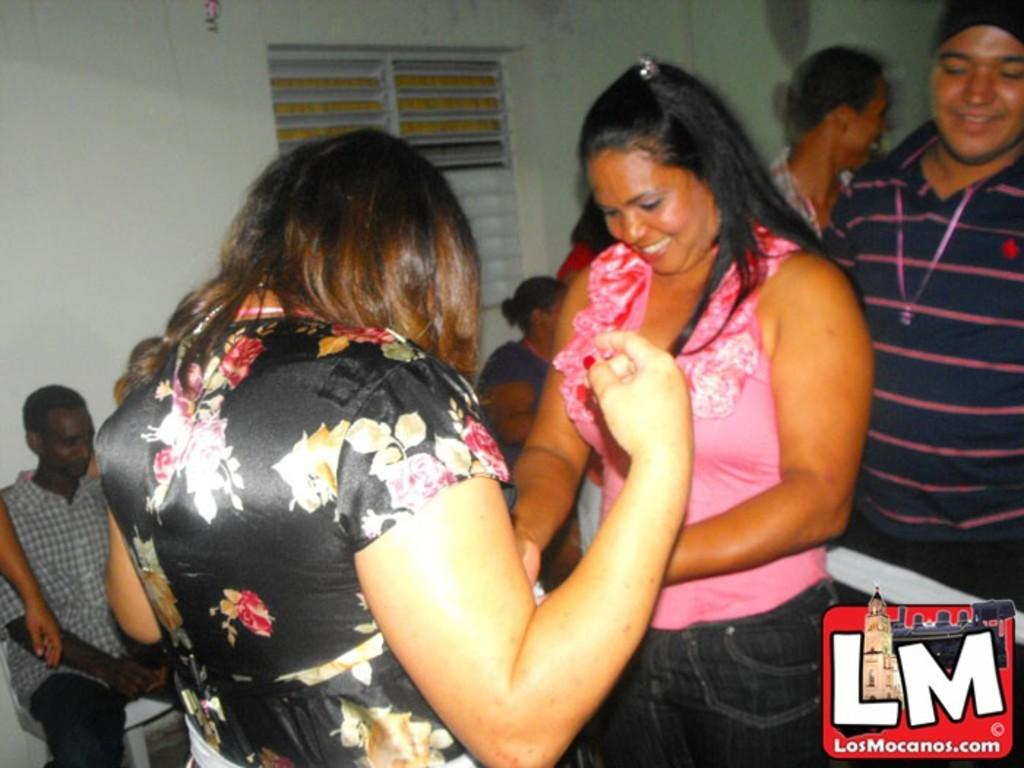How many people are in the image? There is a group of people in the image, but the exact number cannot be determined from the provided facts. What are some people doing in the image? Some people are sitting on chairs, while others are standing. Where is the logo located in the image? The logo is in the bottom right-hand corner of the image. What else is present in the bottom right-hand corner of the image? There is some text in the bottom right-hand corner of the image. What type of seed is being planted by the person in the image? There is no person planting a seed in the image; it features a group of people, some sitting on chairs and others standing. How many legs does the sheet have in the image? There is no sheet present in the image. 